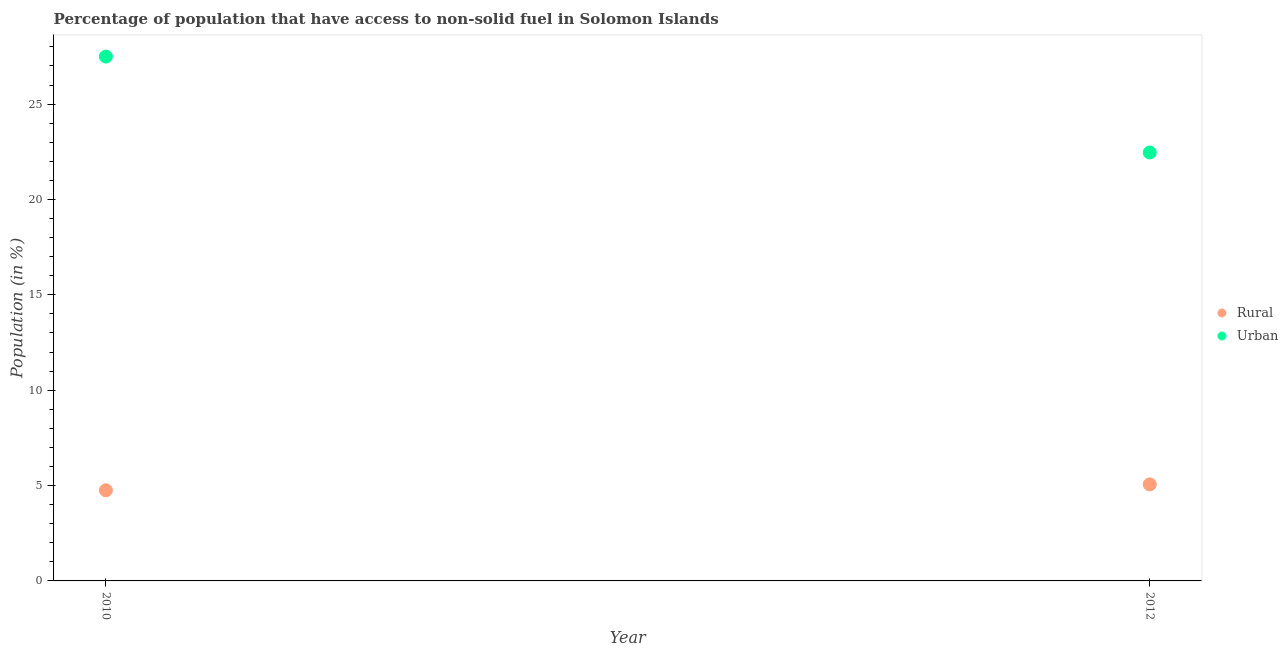Is the number of dotlines equal to the number of legend labels?
Provide a short and direct response. Yes. What is the urban population in 2012?
Make the answer very short. 22.46. Across all years, what is the maximum urban population?
Keep it short and to the point. 27.49. Across all years, what is the minimum urban population?
Ensure brevity in your answer.  22.46. What is the total urban population in the graph?
Keep it short and to the point. 49.96. What is the difference between the urban population in 2010 and that in 2012?
Your answer should be very brief. 5.03. What is the difference between the urban population in 2010 and the rural population in 2012?
Offer a very short reply. 22.43. What is the average rural population per year?
Provide a short and direct response. 4.91. In the year 2010, what is the difference between the urban population and rural population?
Ensure brevity in your answer.  22.74. In how many years, is the rural population greater than 13 %?
Offer a terse response. 0. What is the ratio of the urban population in 2010 to that in 2012?
Provide a succinct answer. 1.22. In how many years, is the rural population greater than the average rural population taken over all years?
Keep it short and to the point. 1. Is the rural population strictly less than the urban population over the years?
Ensure brevity in your answer.  Yes. How many years are there in the graph?
Your answer should be compact. 2. Are the values on the major ticks of Y-axis written in scientific E-notation?
Your response must be concise. No. What is the title of the graph?
Your response must be concise. Percentage of population that have access to non-solid fuel in Solomon Islands. Does "Female population" appear as one of the legend labels in the graph?
Make the answer very short. No. What is the label or title of the X-axis?
Keep it short and to the point. Year. What is the label or title of the Y-axis?
Your response must be concise. Population (in %). What is the Population (in %) in Rural in 2010?
Ensure brevity in your answer.  4.75. What is the Population (in %) in Urban in 2010?
Your answer should be very brief. 27.49. What is the Population (in %) of Rural in 2012?
Provide a short and direct response. 5.06. What is the Population (in %) in Urban in 2012?
Keep it short and to the point. 22.46. Across all years, what is the maximum Population (in %) in Rural?
Offer a terse response. 5.06. Across all years, what is the maximum Population (in %) in Urban?
Provide a short and direct response. 27.49. Across all years, what is the minimum Population (in %) of Rural?
Provide a succinct answer. 4.75. Across all years, what is the minimum Population (in %) of Urban?
Offer a very short reply. 22.46. What is the total Population (in %) in Rural in the graph?
Ensure brevity in your answer.  9.81. What is the total Population (in %) of Urban in the graph?
Give a very brief answer. 49.96. What is the difference between the Population (in %) of Rural in 2010 and that in 2012?
Your response must be concise. -0.31. What is the difference between the Population (in %) of Urban in 2010 and that in 2012?
Offer a terse response. 5.03. What is the difference between the Population (in %) of Rural in 2010 and the Population (in %) of Urban in 2012?
Offer a terse response. -17.71. What is the average Population (in %) of Rural per year?
Provide a short and direct response. 4.91. What is the average Population (in %) of Urban per year?
Your answer should be compact. 24.98. In the year 2010, what is the difference between the Population (in %) of Rural and Population (in %) of Urban?
Provide a short and direct response. -22.74. In the year 2012, what is the difference between the Population (in %) in Rural and Population (in %) in Urban?
Your answer should be very brief. -17.4. What is the ratio of the Population (in %) in Rural in 2010 to that in 2012?
Provide a succinct answer. 0.94. What is the ratio of the Population (in %) in Urban in 2010 to that in 2012?
Keep it short and to the point. 1.22. What is the difference between the highest and the second highest Population (in %) of Rural?
Keep it short and to the point. 0.31. What is the difference between the highest and the second highest Population (in %) of Urban?
Offer a very short reply. 5.03. What is the difference between the highest and the lowest Population (in %) of Rural?
Give a very brief answer. 0.31. What is the difference between the highest and the lowest Population (in %) of Urban?
Make the answer very short. 5.03. 